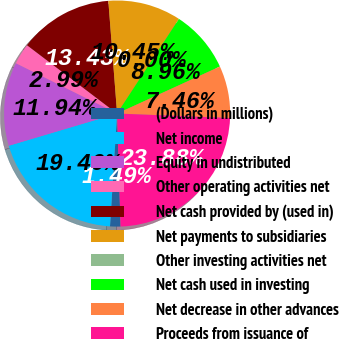Convert chart. <chart><loc_0><loc_0><loc_500><loc_500><pie_chart><fcel>(Dollars in millions)<fcel>Net income<fcel>Equity in undistributed<fcel>Other operating activities net<fcel>Net cash provided by (used in)<fcel>Net payments to subsidiaries<fcel>Other investing activities net<fcel>Net cash used in investing<fcel>Net decrease in other advances<fcel>Proceeds from issuance of<nl><fcel>1.49%<fcel>19.4%<fcel>11.94%<fcel>2.99%<fcel>13.43%<fcel>10.45%<fcel>0.0%<fcel>8.96%<fcel>7.46%<fcel>23.88%<nl></chart> 